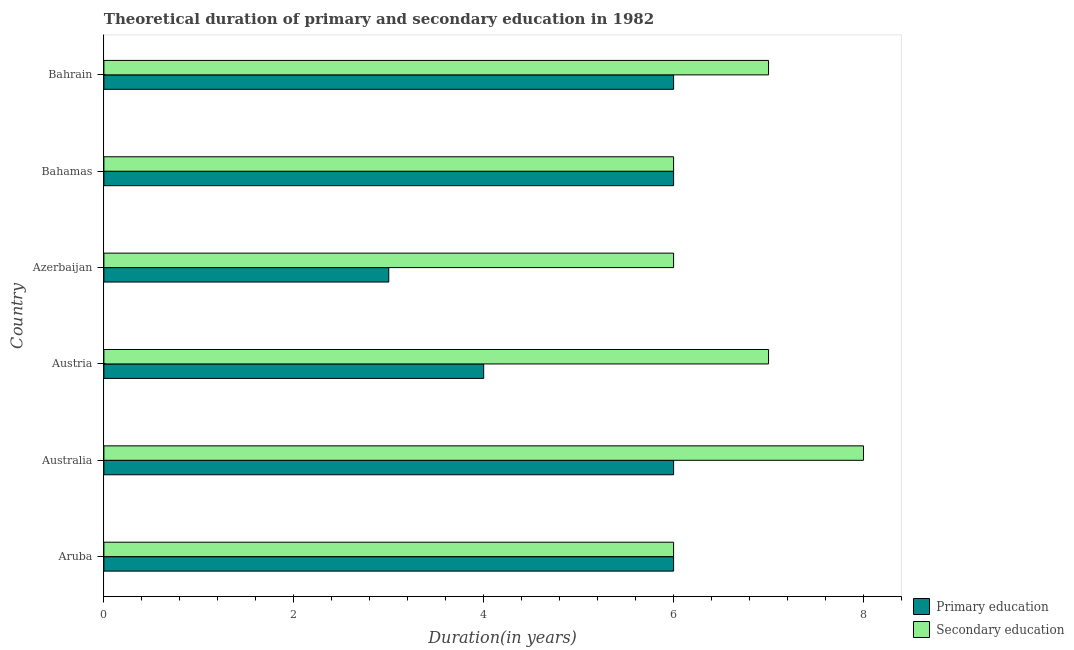What is the label of the 6th group of bars from the top?
Make the answer very short. Aruba. What is the duration of primary education in Bahamas?
Your answer should be compact. 6. Across all countries, what is the maximum duration of secondary education?
Provide a short and direct response. 8. Across all countries, what is the minimum duration of primary education?
Offer a terse response. 3. In which country was the duration of primary education maximum?
Make the answer very short. Aruba. In which country was the duration of secondary education minimum?
Keep it short and to the point. Aruba. What is the total duration of secondary education in the graph?
Offer a very short reply. 40. What is the difference between the duration of primary education in Austria and that in Azerbaijan?
Make the answer very short. 1. What is the difference between the duration of secondary education in Bahrain and the duration of primary education in Bahamas?
Ensure brevity in your answer.  1. What is the average duration of secondary education per country?
Your answer should be very brief. 6.67. What is the difference between the duration of primary education and duration of secondary education in Bahrain?
Offer a very short reply. -1. In how many countries, is the duration of secondary education greater than 2 years?
Your answer should be compact. 6. What is the ratio of the duration of primary education in Austria to that in Azerbaijan?
Your answer should be compact. 1.33. What is the difference between the highest and the second highest duration of secondary education?
Keep it short and to the point. 1. What is the difference between the highest and the lowest duration of secondary education?
Make the answer very short. 2. What does the 1st bar from the top in Bahamas represents?
Your response must be concise. Secondary education. What does the 2nd bar from the bottom in Azerbaijan represents?
Provide a short and direct response. Secondary education. Are all the bars in the graph horizontal?
Give a very brief answer. Yes. What is the difference between two consecutive major ticks on the X-axis?
Provide a short and direct response. 2. Does the graph contain any zero values?
Provide a succinct answer. No. Does the graph contain grids?
Offer a terse response. No. How are the legend labels stacked?
Your answer should be very brief. Vertical. What is the title of the graph?
Ensure brevity in your answer.  Theoretical duration of primary and secondary education in 1982. Does "Enforce a contract" appear as one of the legend labels in the graph?
Give a very brief answer. No. What is the label or title of the X-axis?
Offer a very short reply. Duration(in years). What is the label or title of the Y-axis?
Provide a succinct answer. Country. What is the Duration(in years) of Secondary education in Aruba?
Give a very brief answer. 6. What is the Duration(in years) of Secondary education in Austria?
Provide a succinct answer. 7. What is the Duration(in years) in Primary education in Azerbaijan?
Make the answer very short. 3. What is the Duration(in years) in Secondary education in Bahamas?
Provide a succinct answer. 6. What is the Duration(in years) of Primary education in Bahrain?
Ensure brevity in your answer.  6. Across all countries, what is the minimum Duration(in years) of Primary education?
Your answer should be very brief. 3. Across all countries, what is the minimum Duration(in years) in Secondary education?
Your answer should be compact. 6. What is the total Duration(in years) in Primary education in the graph?
Your answer should be very brief. 31. What is the total Duration(in years) of Secondary education in the graph?
Your response must be concise. 40. What is the difference between the Duration(in years) of Secondary education in Aruba and that in Australia?
Your response must be concise. -2. What is the difference between the Duration(in years) of Primary education in Aruba and that in Austria?
Provide a succinct answer. 2. What is the difference between the Duration(in years) in Secondary education in Aruba and that in Austria?
Give a very brief answer. -1. What is the difference between the Duration(in years) in Secondary education in Aruba and that in Azerbaijan?
Make the answer very short. 0. What is the difference between the Duration(in years) of Secondary education in Aruba and that in Bahrain?
Your answer should be compact. -1. What is the difference between the Duration(in years) in Secondary education in Australia and that in Austria?
Ensure brevity in your answer.  1. What is the difference between the Duration(in years) of Secondary education in Australia and that in Bahamas?
Provide a short and direct response. 2. What is the difference between the Duration(in years) in Primary education in Australia and that in Bahrain?
Make the answer very short. 0. What is the difference between the Duration(in years) of Secondary education in Austria and that in Azerbaijan?
Ensure brevity in your answer.  1. What is the difference between the Duration(in years) of Secondary education in Austria and that in Bahamas?
Provide a short and direct response. 1. What is the difference between the Duration(in years) of Primary education in Azerbaijan and that in Bahamas?
Give a very brief answer. -3. What is the difference between the Duration(in years) in Secondary education in Azerbaijan and that in Bahamas?
Offer a terse response. 0. What is the difference between the Duration(in years) in Secondary education in Azerbaijan and that in Bahrain?
Your answer should be very brief. -1. What is the difference between the Duration(in years) in Primary education in Aruba and the Duration(in years) in Secondary education in Bahamas?
Make the answer very short. 0. What is the difference between the Duration(in years) in Primary education in Aruba and the Duration(in years) in Secondary education in Bahrain?
Your answer should be very brief. -1. What is the difference between the Duration(in years) of Primary education in Australia and the Duration(in years) of Secondary education in Austria?
Provide a short and direct response. -1. What is the difference between the Duration(in years) of Primary education in Australia and the Duration(in years) of Secondary education in Azerbaijan?
Keep it short and to the point. 0. What is the difference between the Duration(in years) in Primary education in Australia and the Duration(in years) in Secondary education in Bahamas?
Keep it short and to the point. 0. What is the difference between the Duration(in years) in Primary education in Australia and the Duration(in years) in Secondary education in Bahrain?
Offer a very short reply. -1. What is the difference between the Duration(in years) in Primary education in Austria and the Duration(in years) in Secondary education in Azerbaijan?
Offer a very short reply. -2. What is the difference between the Duration(in years) of Primary education in Azerbaijan and the Duration(in years) of Secondary education in Bahrain?
Your answer should be compact. -4. What is the difference between the Duration(in years) of Primary education in Bahamas and the Duration(in years) of Secondary education in Bahrain?
Provide a short and direct response. -1. What is the average Duration(in years) in Primary education per country?
Keep it short and to the point. 5.17. What is the difference between the Duration(in years) in Primary education and Duration(in years) in Secondary education in Aruba?
Provide a short and direct response. 0. What is the difference between the Duration(in years) in Primary education and Duration(in years) in Secondary education in Australia?
Your response must be concise. -2. What is the ratio of the Duration(in years) in Secondary education in Aruba to that in Australia?
Give a very brief answer. 0.75. What is the ratio of the Duration(in years) of Primary education in Aruba to that in Austria?
Your response must be concise. 1.5. What is the ratio of the Duration(in years) of Secondary education in Aruba to that in Bahamas?
Offer a terse response. 1. What is the ratio of the Duration(in years) of Primary education in Aruba to that in Bahrain?
Keep it short and to the point. 1. What is the ratio of the Duration(in years) of Secondary education in Aruba to that in Bahrain?
Ensure brevity in your answer.  0.86. What is the ratio of the Duration(in years) in Secondary education in Australia to that in Austria?
Your response must be concise. 1.14. What is the ratio of the Duration(in years) of Secondary education in Australia to that in Azerbaijan?
Keep it short and to the point. 1.33. What is the ratio of the Duration(in years) of Primary education in Australia to that in Bahamas?
Offer a terse response. 1. What is the ratio of the Duration(in years) in Secondary education in Australia to that in Bahamas?
Provide a succinct answer. 1.33. What is the ratio of the Duration(in years) of Primary education in Australia to that in Bahrain?
Your answer should be compact. 1. What is the ratio of the Duration(in years) in Secondary education in Australia to that in Bahrain?
Offer a very short reply. 1.14. What is the ratio of the Duration(in years) in Primary education in Austria to that in Bahrain?
Give a very brief answer. 0.67. What is the ratio of the Duration(in years) of Secondary education in Austria to that in Bahrain?
Ensure brevity in your answer.  1. What is the ratio of the Duration(in years) in Primary education in Azerbaijan to that in Bahrain?
Keep it short and to the point. 0.5. What is the ratio of the Duration(in years) in Primary education in Bahamas to that in Bahrain?
Offer a very short reply. 1. What is the ratio of the Duration(in years) of Secondary education in Bahamas to that in Bahrain?
Make the answer very short. 0.86. What is the difference between the highest and the second highest Duration(in years) in Primary education?
Ensure brevity in your answer.  0. What is the difference between the highest and the second highest Duration(in years) in Secondary education?
Your response must be concise. 1. What is the difference between the highest and the lowest Duration(in years) in Primary education?
Your answer should be compact. 3. What is the difference between the highest and the lowest Duration(in years) of Secondary education?
Offer a very short reply. 2. 